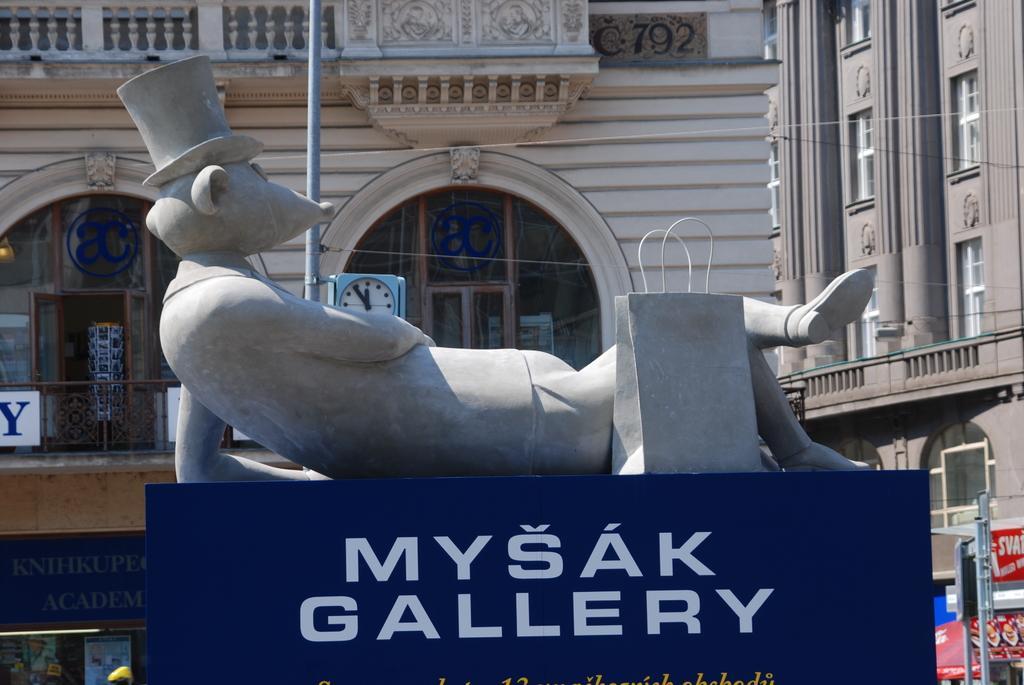Please provide a concise description of this image. In this picture we can see a statue and a name board and in the background we can see buildings and some objects. 